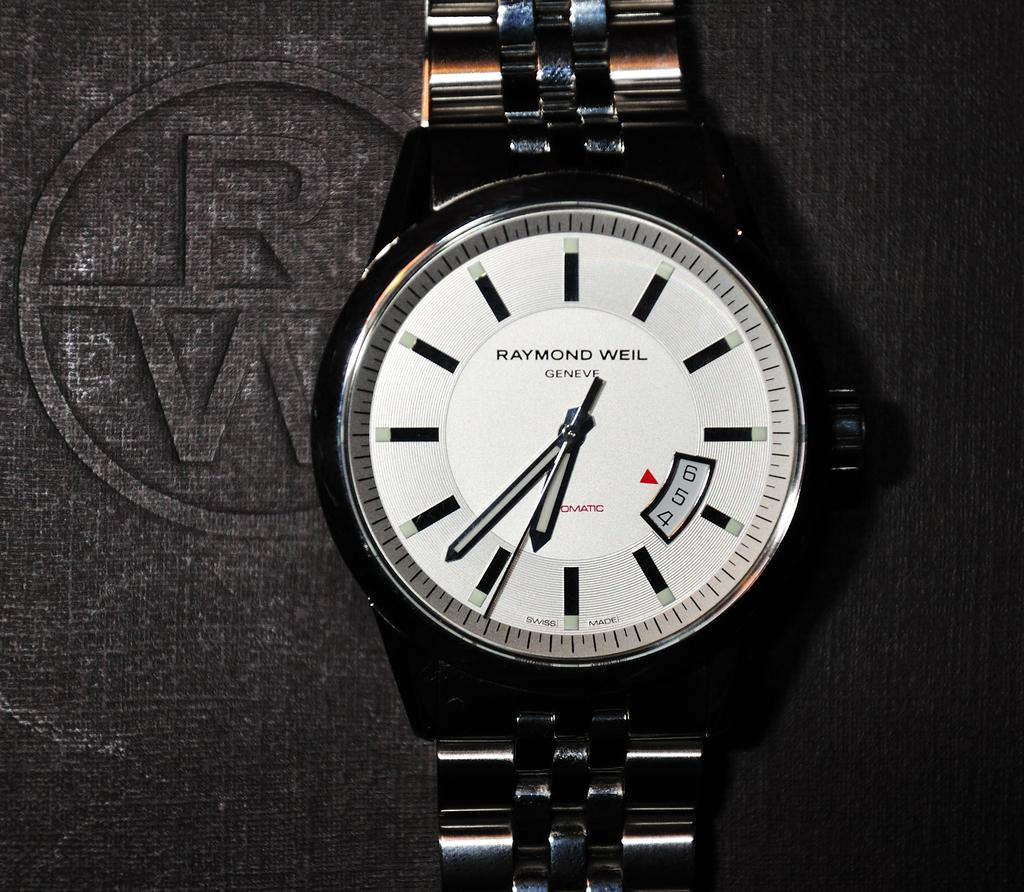<image>
Render a clear and concise summary of the photo. Face of a watch which says Raymond Weil on it. 